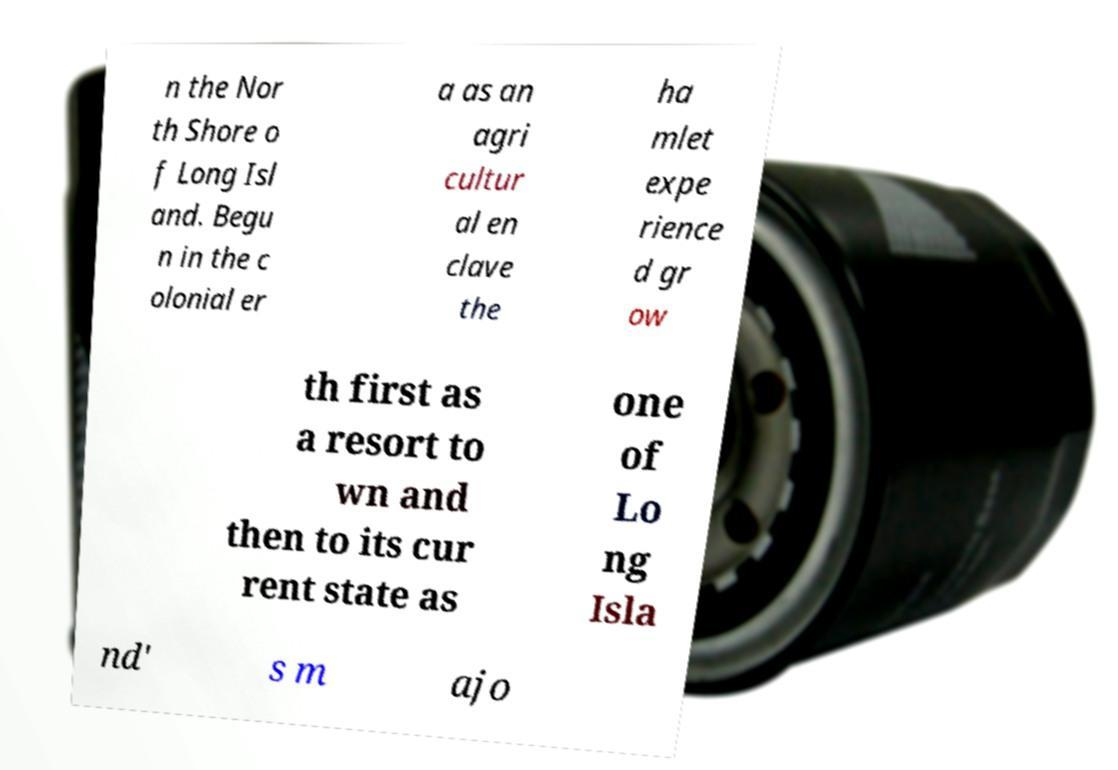What messages or text are displayed in this image? I need them in a readable, typed format. n the Nor th Shore o f Long Isl and. Begu n in the c olonial er a as an agri cultur al en clave the ha mlet expe rience d gr ow th first as a resort to wn and then to its cur rent state as one of Lo ng Isla nd' s m ajo 